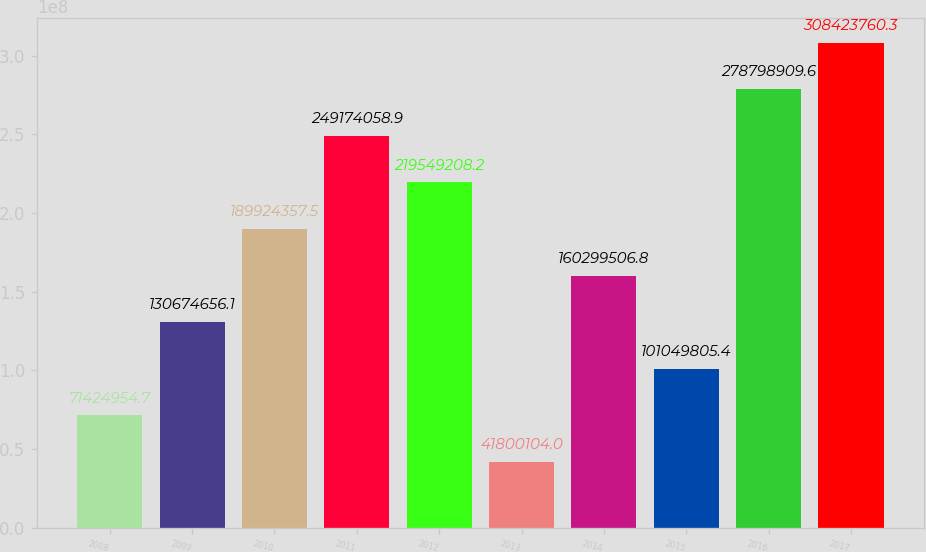Convert chart. <chart><loc_0><loc_0><loc_500><loc_500><bar_chart><fcel>2008<fcel>2009<fcel>2010<fcel>2011<fcel>2012<fcel>2013<fcel>2014<fcel>2015<fcel>2016<fcel>2017<nl><fcel>7.1425e+07<fcel>1.30675e+08<fcel>1.89924e+08<fcel>2.49174e+08<fcel>2.19549e+08<fcel>4.18001e+07<fcel>1.603e+08<fcel>1.0105e+08<fcel>2.78799e+08<fcel>3.08424e+08<nl></chart> 